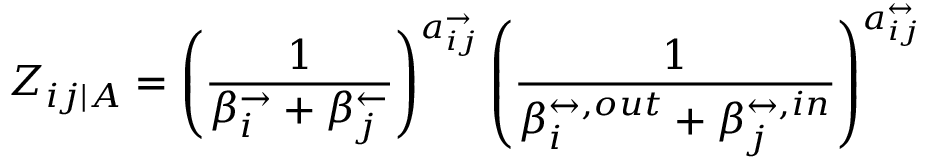Convert formula to latex. <formula><loc_0><loc_0><loc_500><loc_500>Z _ { i j | A } = \left ( \frac { 1 } { \beta _ { i } ^ { \rightarrow } + \beta _ { j } ^ { \leftarrow } } \right ) ^ { a _ { i j } ^ { \rightarrow } } \left ( \frac { 1 } { \beta _ { i } ^ { \leftrightarrow , o u t } + \beta _ { j } ^ { \leftrightarrow , i n } } \right ) ^ { a _ { i j } ^ { \leftrightarrow } }</formula> 